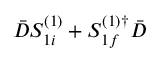Convert formula to latex. <formula><loc_0><loc_0><loc_500><loc_500>\bar { D } S _ { 1 i } ^ { ( 1 ) } + S _ { 1 f } ^ { ( 1 ) \dagger } \bar { D }</formula> 